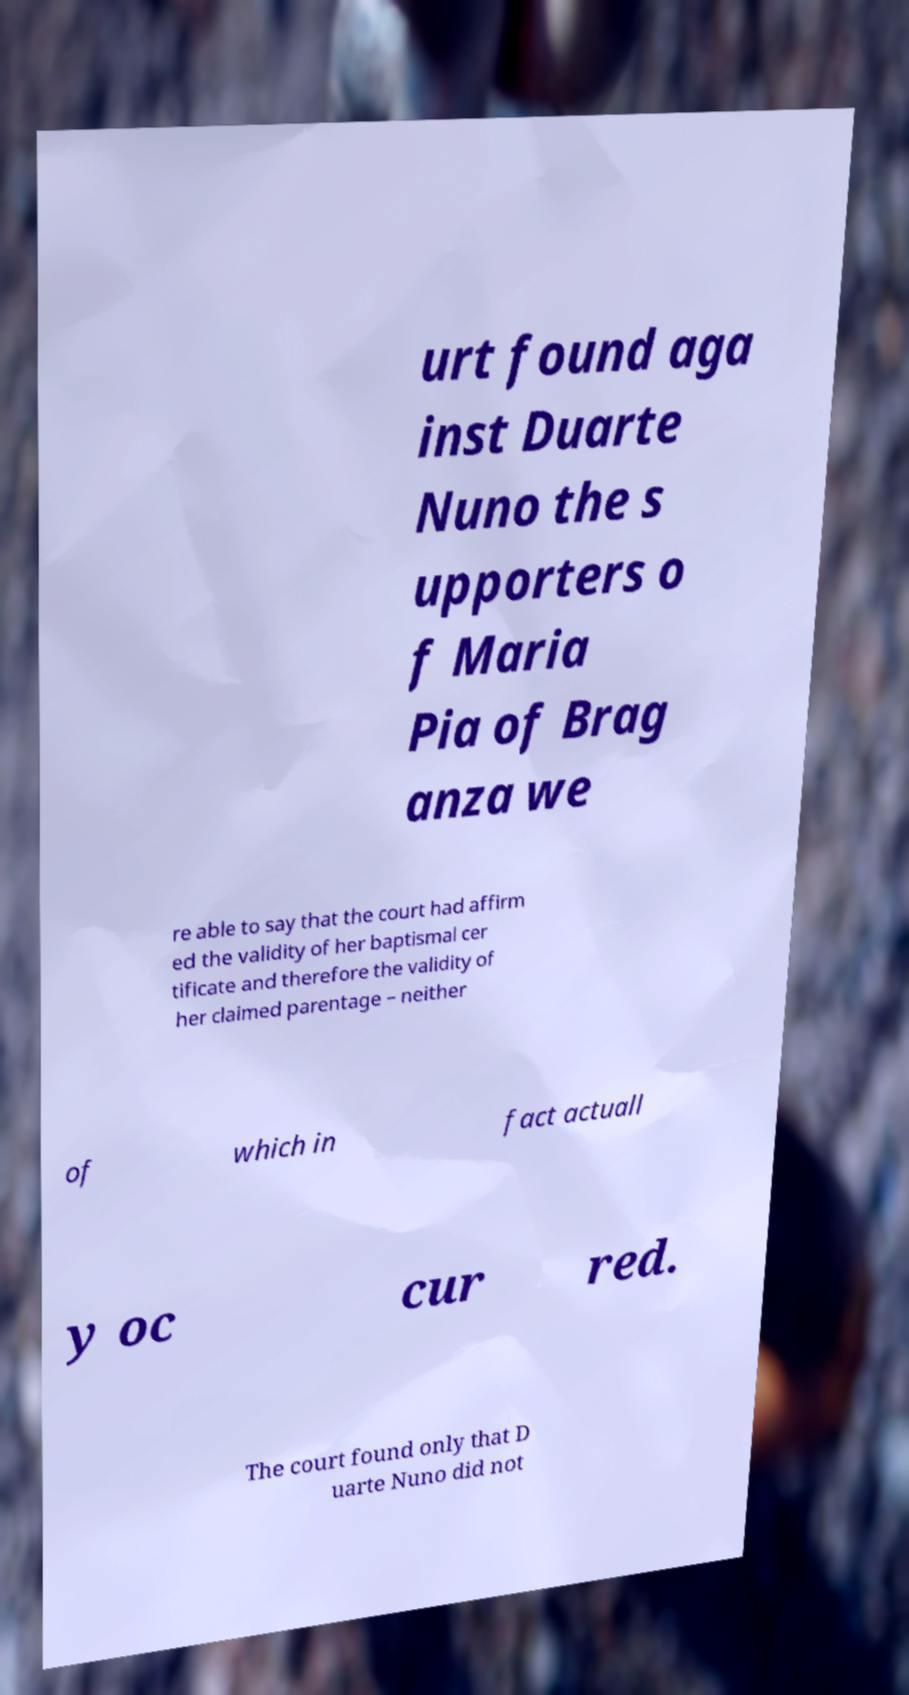Please identify and transcribe the text found in this image. urt found aga inst Duarte Nuno the s upporters o f Maria Pia of Brag anza we re able to say that the court had affirm ed the validity of her baptismal cer tificate and therefore the validity of her claimed parentage – neither of which in fact actuall y oc cur red. The court found only that D uarte Nuno did not 